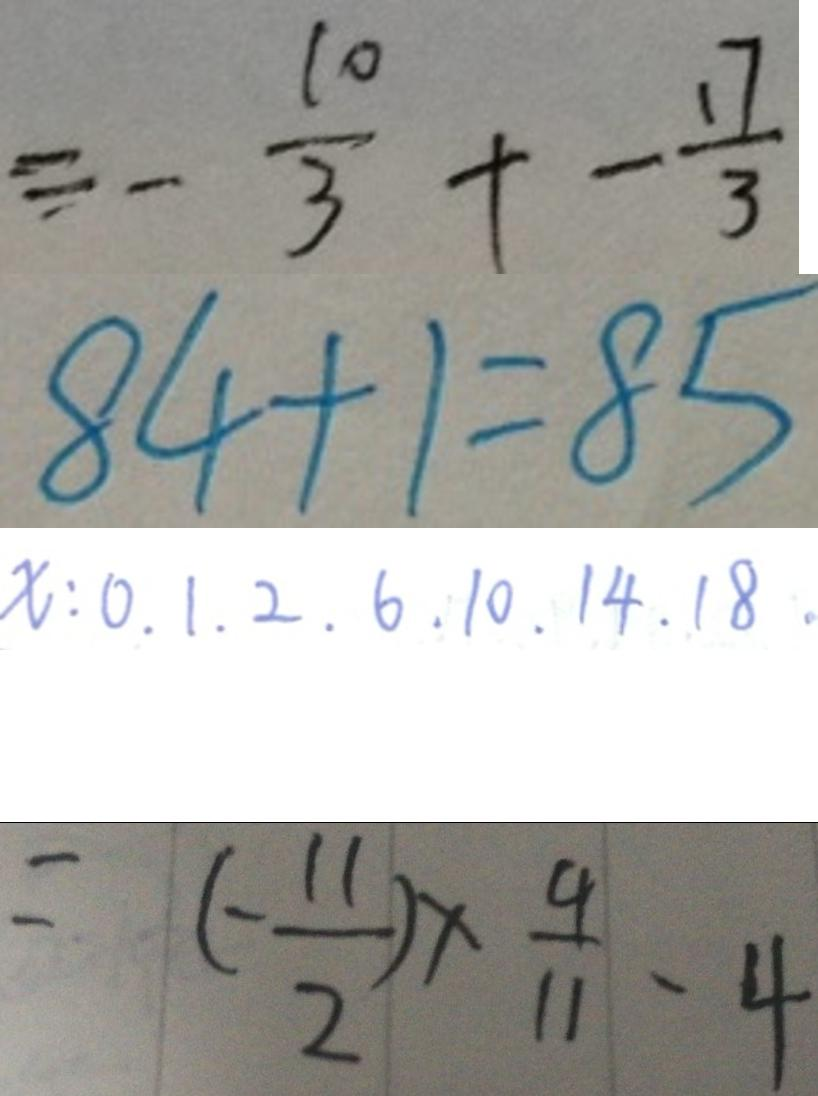Convert formula to latex. <formula><loc_0><loc_0><loc_500><loc_500>\equiv - \frac { 1 0 } { 3 } + - \frac { 1 7 } { 3 } 
 8 4 + 1 = 8 5 
 x : 0 . 1 . 2 . 6 . 1 0 . 1 4 . 1 8 . 
 = ( - \frac { 1 1 } { 2 } ) \times \frac { 4 } { 1 1 } - 4</formula> 